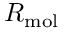Convert formula to latex. <formula><loc_0><loc_0><loc_500><loc_500>R _ { m o l }</formula> 